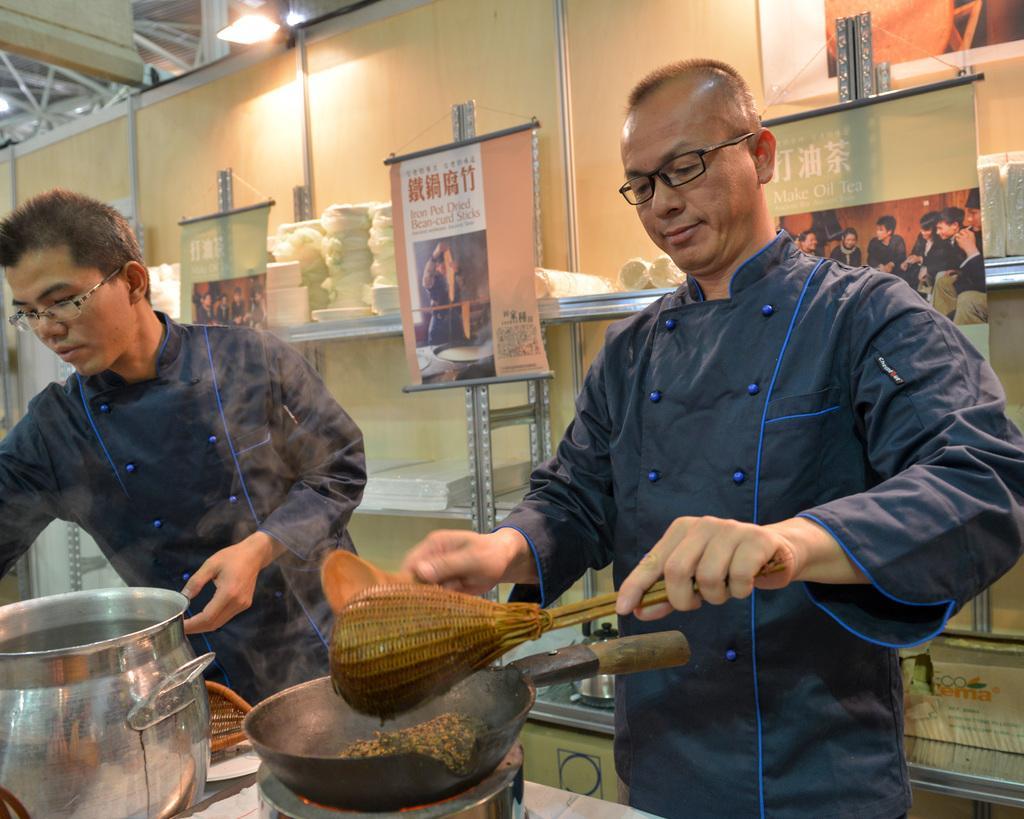Describe this image in one or two sentences. In this picture there are two persons standing and holding the object. There are utensils on the table. At the back there are plates an tissues in the shelf and there is a cardboard in the shelf and there are posters. At the top there are lights. 